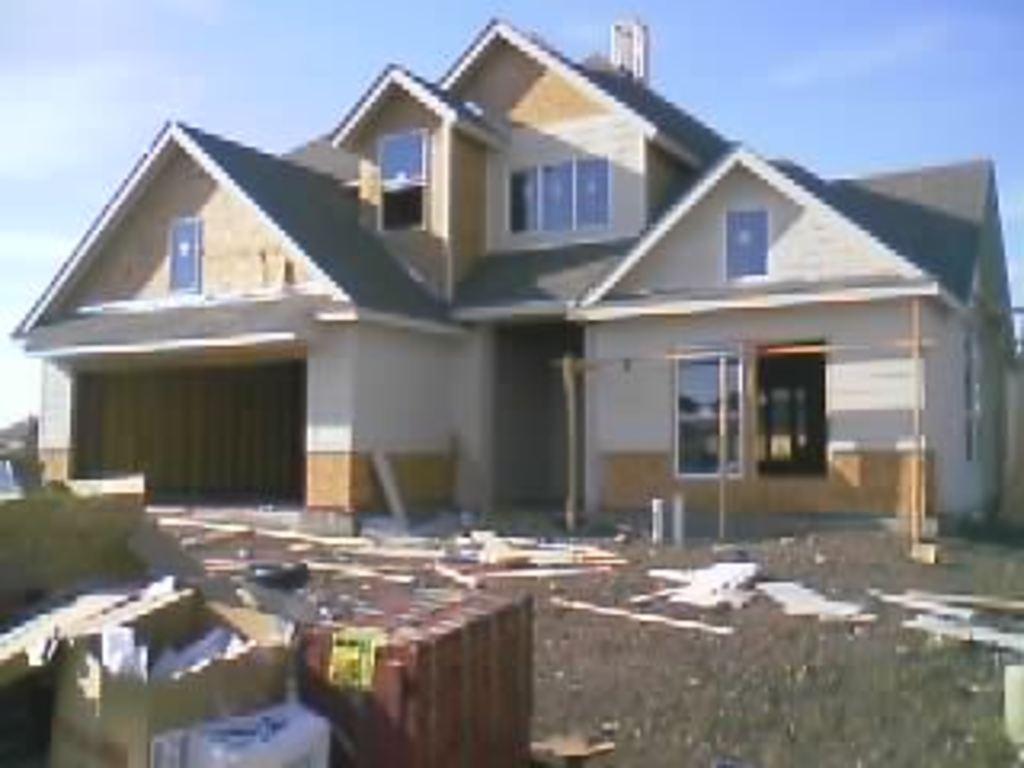Could you give a brief overview of what you see in this image? There are cartons and other items at the left. There is a building at the back. 